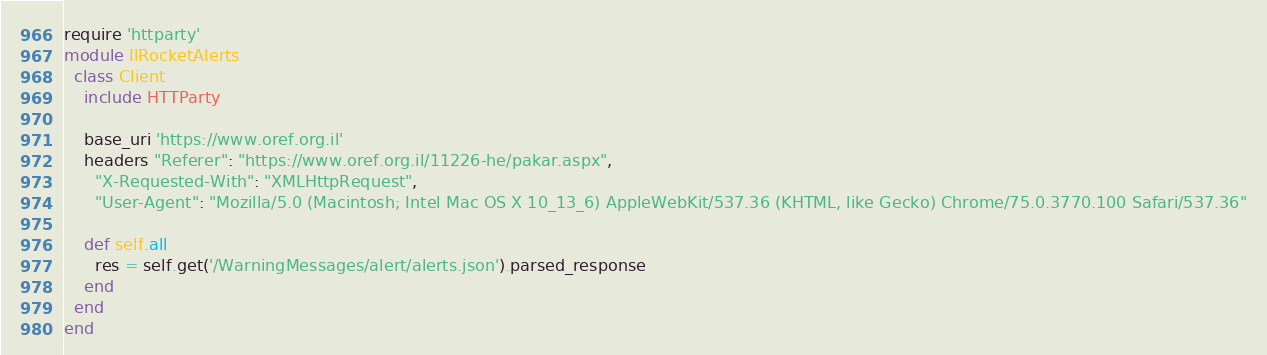<code> <loc_0><loc_0><loc_500><loc_500><_Ruby_>require 'httparty'
module IlRocketAlerts
  class Client
    include HTTParty

    base_uri 'https://www.oref.org.il'
    headers "Referer": "https://www.oref.org.il/11226-he/pakar.aspx",
      "X-Requested-With": "XMLHttpRequest",
      "User-Agent": "Mozilla/5.0 (Macintosh; Intel Mac OS X 10_13_6) AppleWebKit/537.36 (KHTML, like Gecko) Chrome/75.0.3770.100 Safari/537.36"

    def self.all
      res = self.get('/WarningMessages/alert/alerts.json').parsed_response
    end
  end
end</code> 